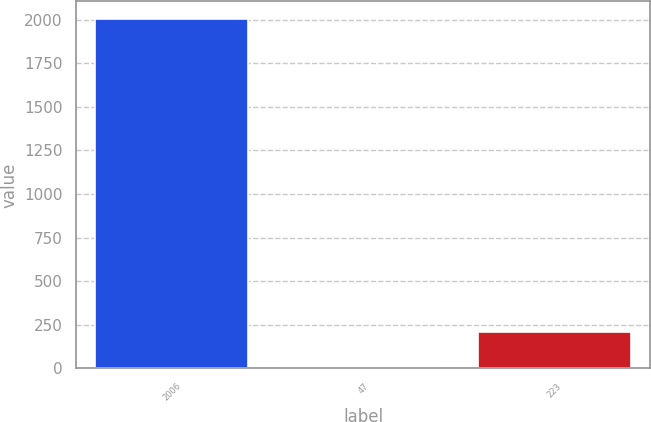<chart> <loc_0><loc_0><loc_500><loc_500><bar_chart><fcel>2006<fcel>47<fcel>223<nl><fcel>2004<fcel>6.2<fcel>205.98<nl></chart> 